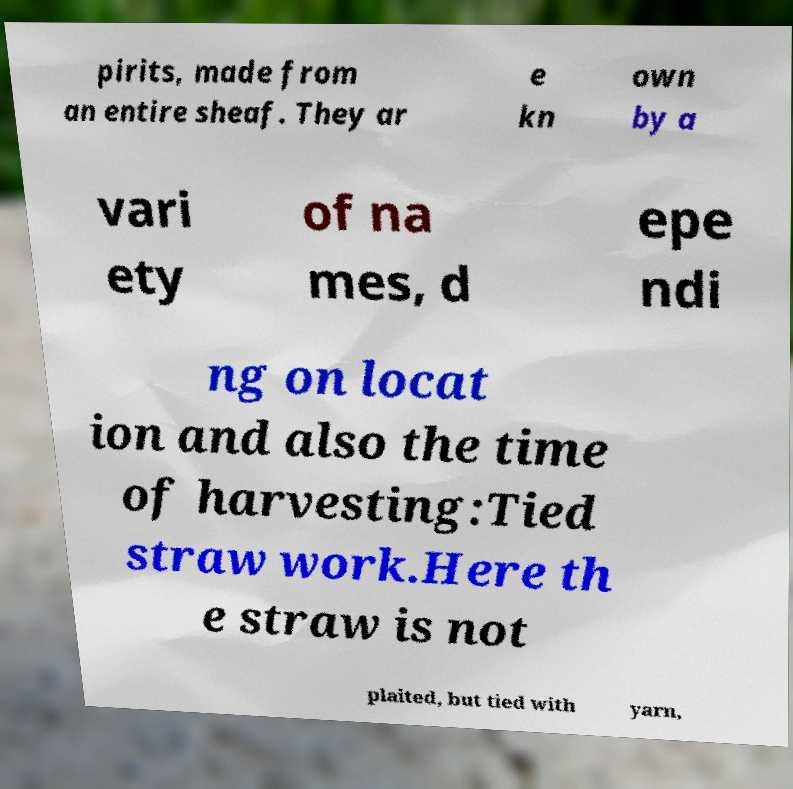There's text embedded in this image that I need extracted. Can you transcribe it verbatim? pirits, made from an entire sheaf. They ar e kn own by a vari ety of na mes, d epe ndi ng on locat ion and also the time of harvesting:Tied straw work.Here th e straw is not plaited, but tied with yarn, 